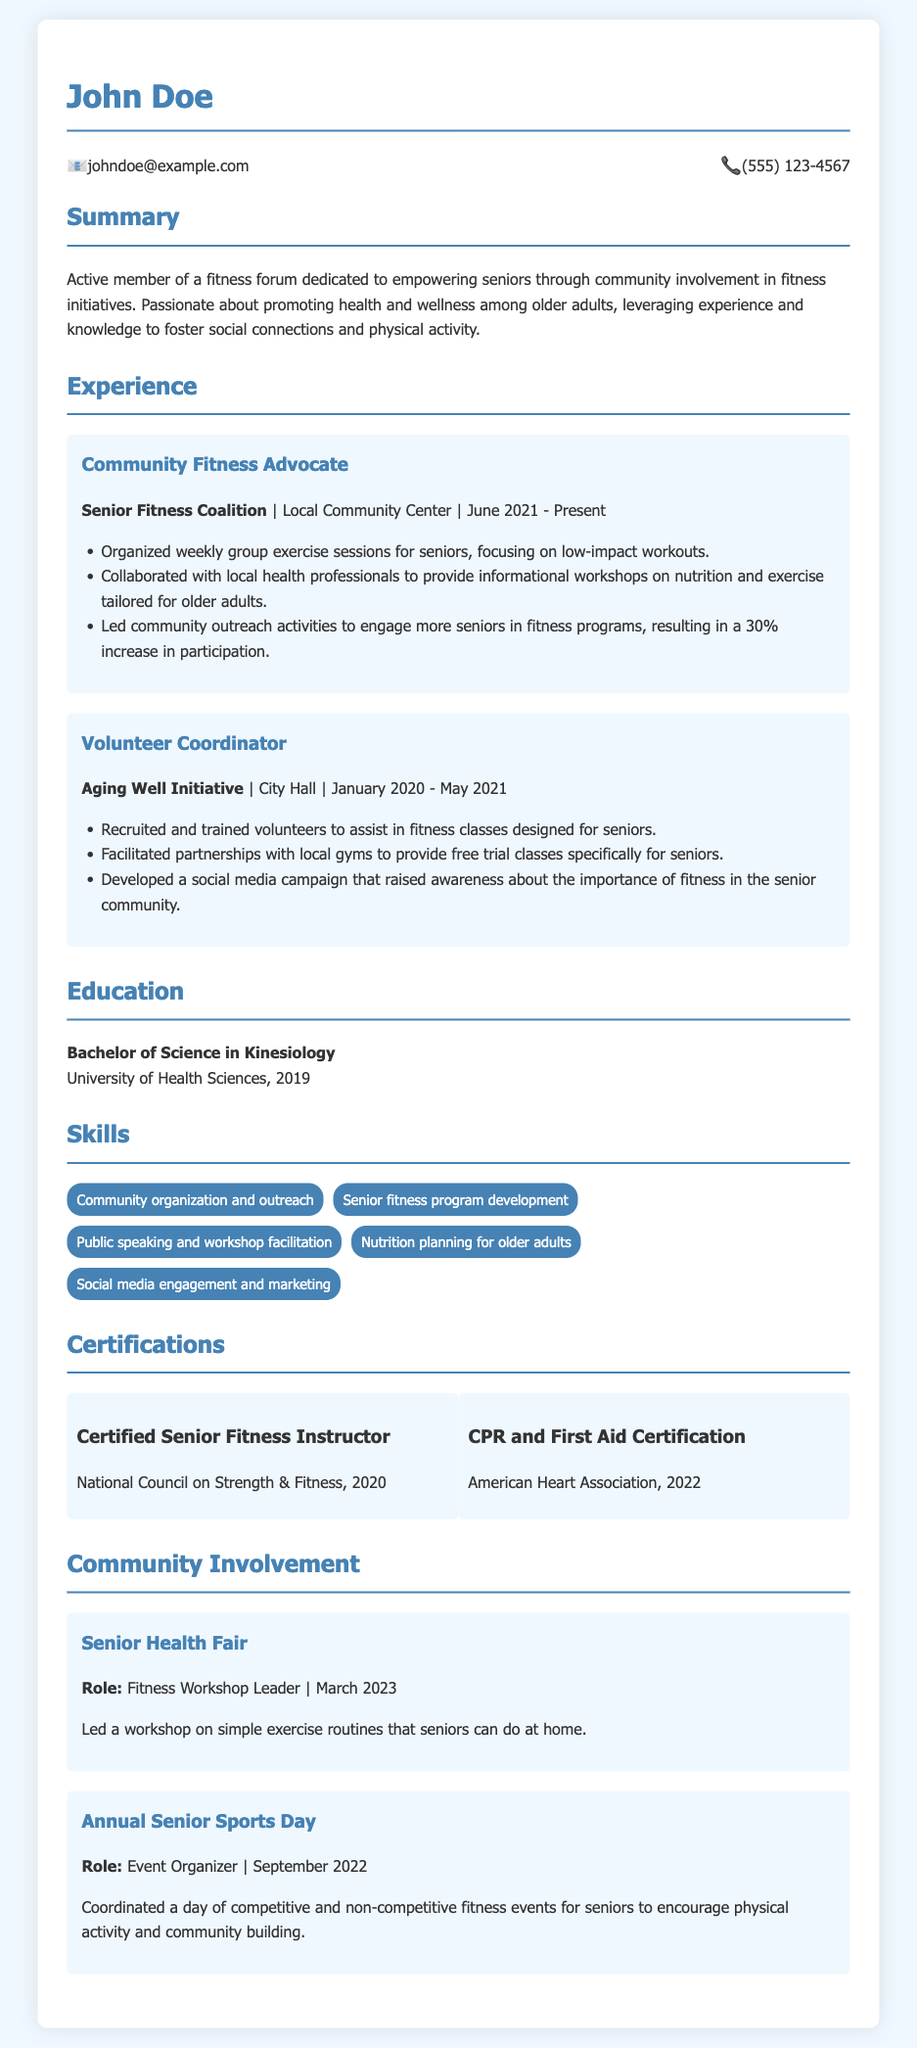what is the name of the community fitness organization? The community fitness organization mentioned in the document is the Senior Fitness Coalition, which John Doe is associated with.
Answer: Senior Fitness Coalition when did John Doe start working as a Community Fitness Advocate? The document states that John Doe started working as a Community Fitness Advocate in June 2021.
Answer: June 2021 which certification does John Doe hold related to senior fitness? The document lists the Certified Senior Fitness Instructor as one of the certifications John Doe holds.
Answer: Certified Senior Fitness Instructor how many skills are listed in the Skills section? The Skills section contains five different skill items related to John Doe's qualifications.
Answer: 5 what event did John Doe organize in September 2022? John Doe organized the Annual Senior Sports Day in September 2022 as part of his community involvement.
Answer: Annual Senior Sports Day what role did John Doe play at the Senior Health Fair? At the Senior Health Fair, John Doe served as the Fitness Workshop Leader.
Answer: Fitness Workshop Leader which academic degree did John Doe obtain? The document indicates that John Doe obtained a Bachelor of Science in Kinesiology from the University of Health Sciences.
Answer: Bachelor of Science in Kinesiology what was the focus of the workshops organized by John Doe? The workshops organized by John Doe focused on nutrition and exercise tailored for older adults.
Answer: Nutrition and exercise how many years was John Doe a Volunteer Coordinator? John Doe served as a Volunteer Coordinator from January 2020 to May 2021, which amounts to approximately one year and four months.
Answer: 1 year and 4 months 